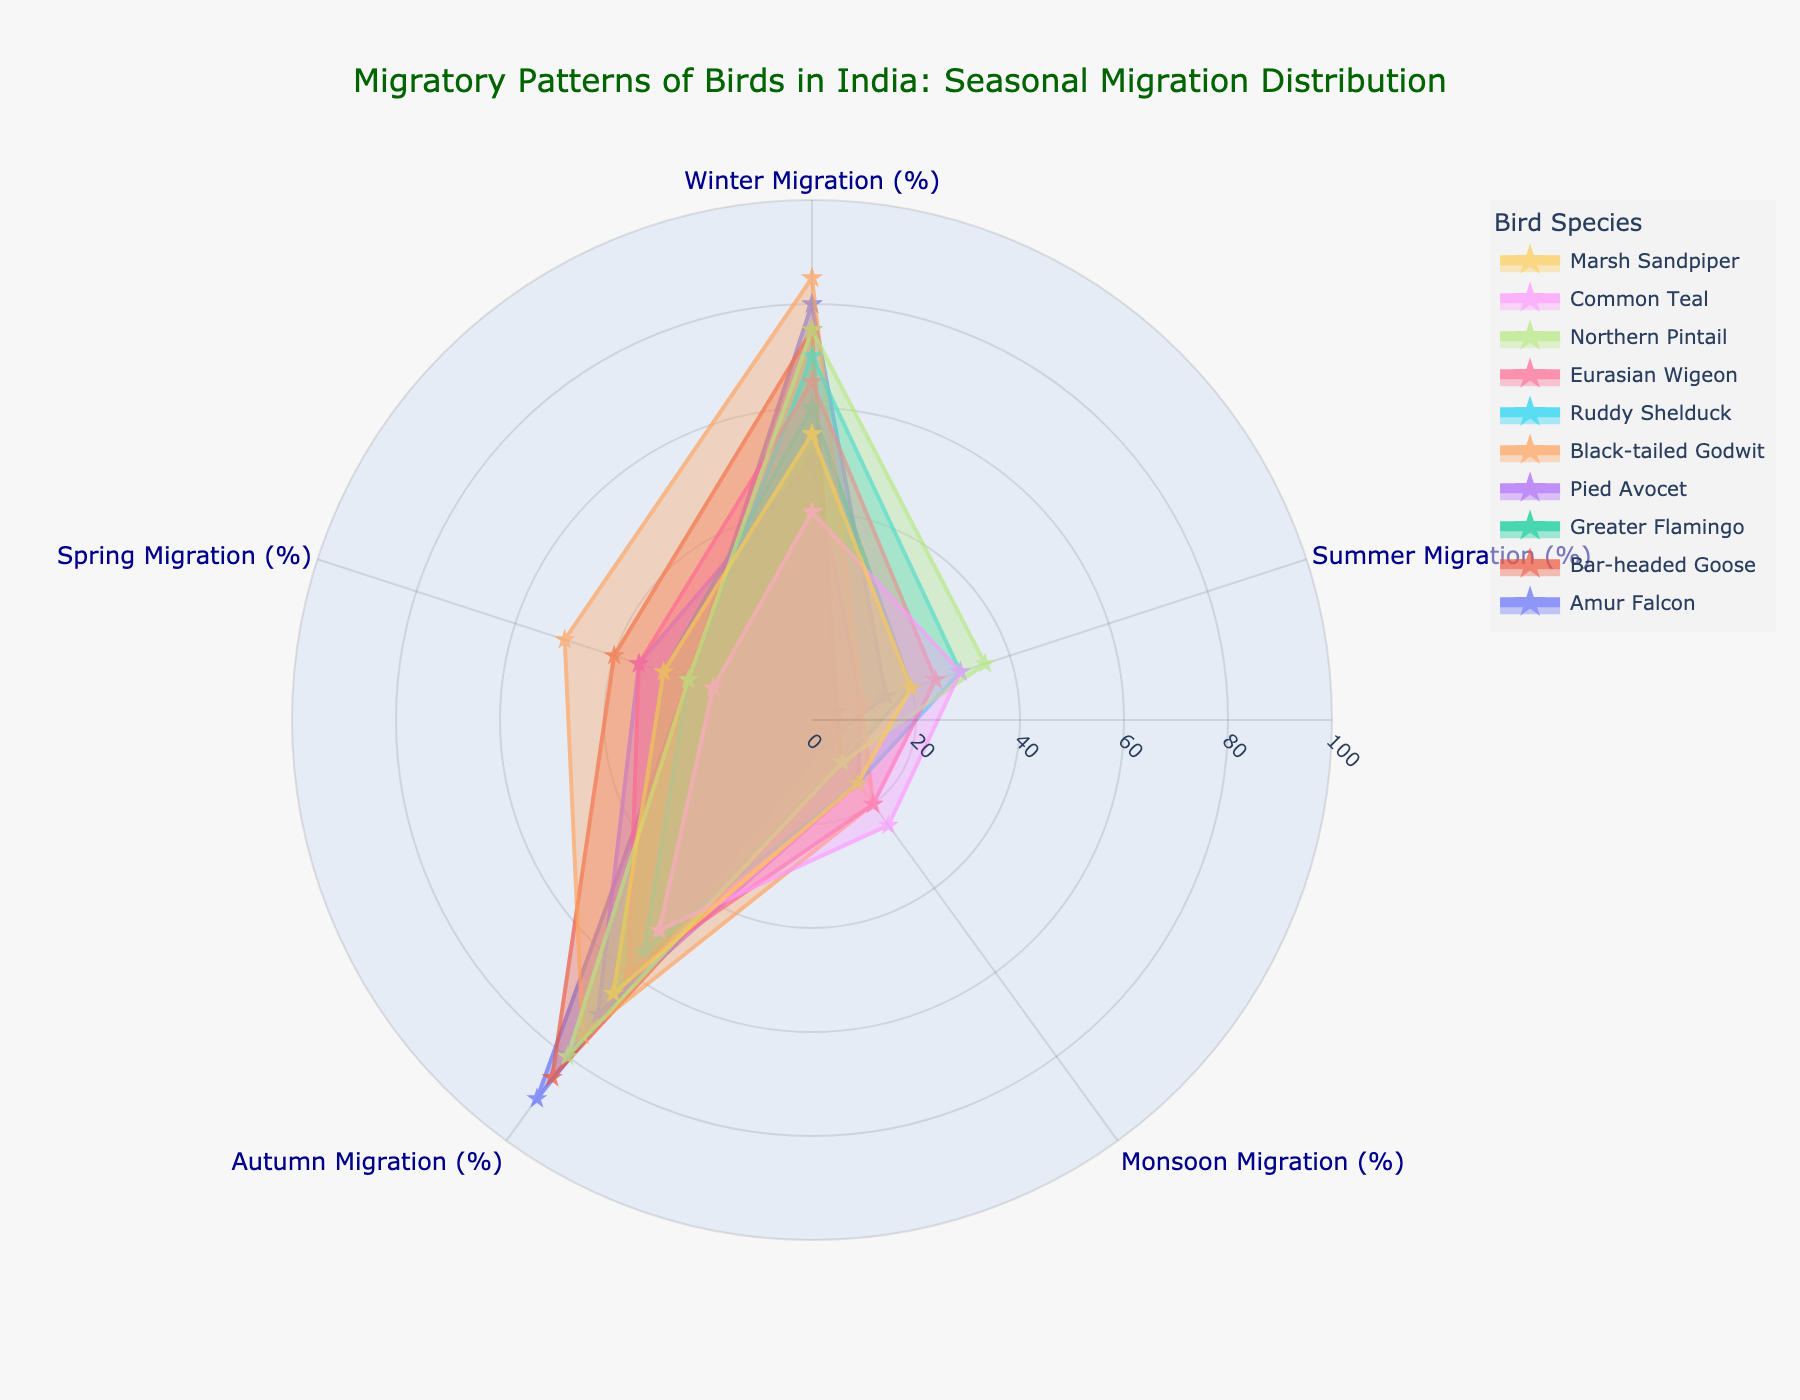What's the title of the radar chart? The text is displayed prominently at the top center of the chart. It reads "Migratory Patterns of Birds in India: Seasonal Migration Distribution".
Answer: Migratory Patterns of Birds in India: Seasonal Migration Distribution Which bird species shows the highest migration during winter? Look for the species with the highest percentual value in the Winter Migration segment. The Black-tailed Godwit has the highest value with 85%.
Answer: Black-tailed Godwit In which season does the Pied Avocet have the highest migration percentage? Observe the segments associated with the Pied Avocet, and identify the one with the highest percentage. The Autumn Migration is highest at 70%.
Answer: Autumn Migration What is the average migration percentage for the Marsh Sandpiper across all seasons? Sum the values for all seasons (55, 20, 15, 65, 30), then divide by the number of seasons. (55 + 20 + 15 + 65 + 30) / 5 = 37.
Answer: 37% Which bird species migrates the least during the summer? Compare the Summer Migration percentage of all species and find the smallest value. The Bar-headed Goose has the lowest value at 5%.
Answer: Bar-headed Goose How does the migration pattern of the Amur Falcon compare between Winter and Autumn? Compare the values in Winter Migration (80%) and Autumn Migration (90%) for the Amur Falcon. Autumn Migration is higher by 10%.
Answer: Autumn Migration is higher Which bird species has the closest migration percentages between Spring and Summer? Examine and compare the migration percentages between Spring and Summer for all bird species. The Eurasian Wigeon has Spring at 35% and Summer at 25%, closest among all.
Answer: Eurasian Wigeon What is the general trend in migration percentages across seasons for the Northern Pintail? Observe the migration values by season. The values are Winter (75%), Summer (35%), Monsoon (10%), Autumn (80%), and Spring (25%). The general trend shows high migration in Winter and Autumn, low in Monsoon and Spring, and moderate in Summer.
Answer: High in Winter and Autumn, low in Monsoon and Spring, moderate in Summer 